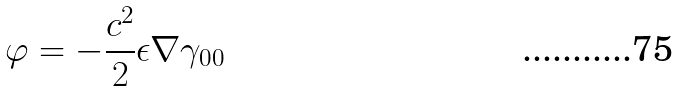<formula> <loc_0><loc_0><loc_500><loc_500>\varphi = - \frac { c ^ { 2 } } { 2 } \epsilon \nabla \gamma _ { 0 0 }</formula> 